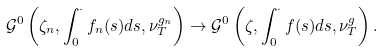<formula> <loc_0><loc_0><loc_500><loc_500>\mathcal { G } ^ { 0 } \left ( \zeta _ { n } , \int _ { 0 } ^ { \cdot } f _ { n } ( s ) d s , \nu _ { T } ^ { g _ { n } } \right ) \rightarrow \mathcal { G } ^ { 0 } \left ( \zeta , \int _ { 0 } ^ { \cdot } f ( s ) d s , \nu _ { T } ^ { g } \right ) .</formula> 